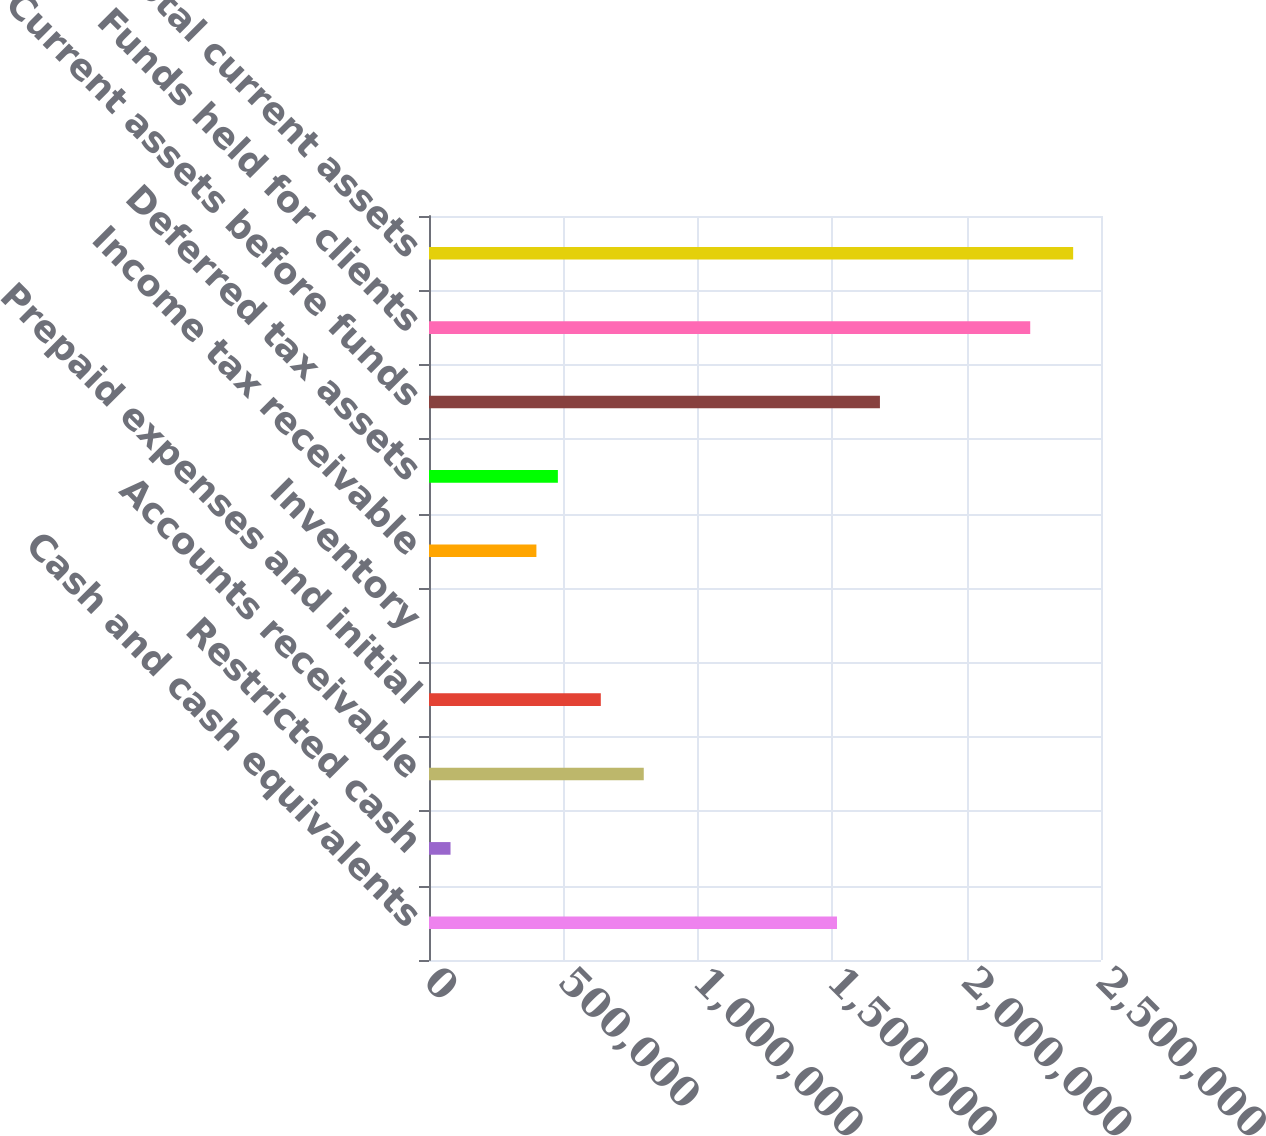Convert chart. <chart><loc_0><loc_0><loc_500><loc_500><bar_chart><fcel>Cash and cash equivalents<fcel>Restricted cash<fcel>Accounts receivable<fcel>Prepaid expenses and initial<fcel>Inventory<fcel>Income tax receivable<fcel>Deferred tax assets<fcel>Current assets before funds<fcel>Funds held for clients<fcel>Total current assets<nl><fcel>1.51781e+06<fcel>80069.7<fcel>798942<fcel>639193<fcel>195<fcel>399568<fcel>479443<fcel>1.67756e+06<fcel>2.23669e+06<fcel>2.39644e+06<nl></chart> 